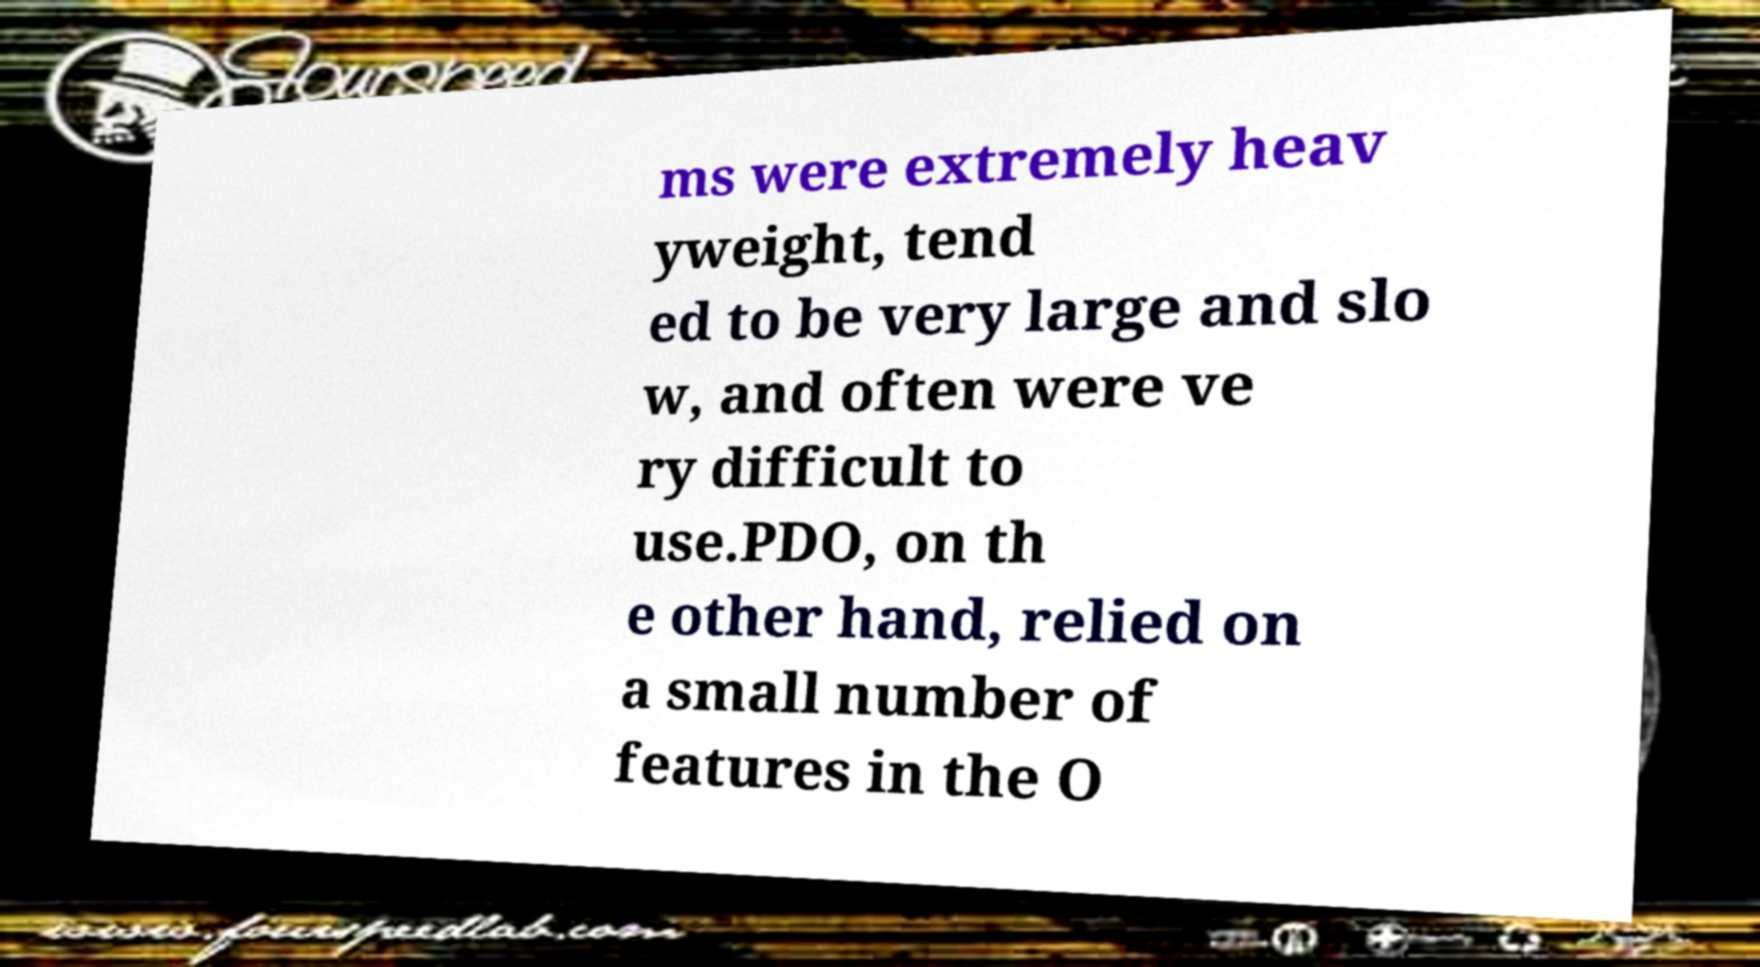Could you assist in decoding the text presented in this image and type it out clearly? ms were extremely heav yweight, tend ed to be very large and slo w, and often were ve ry difficult to use.PDO, on th e other hand, relied on a small number of features in the O 